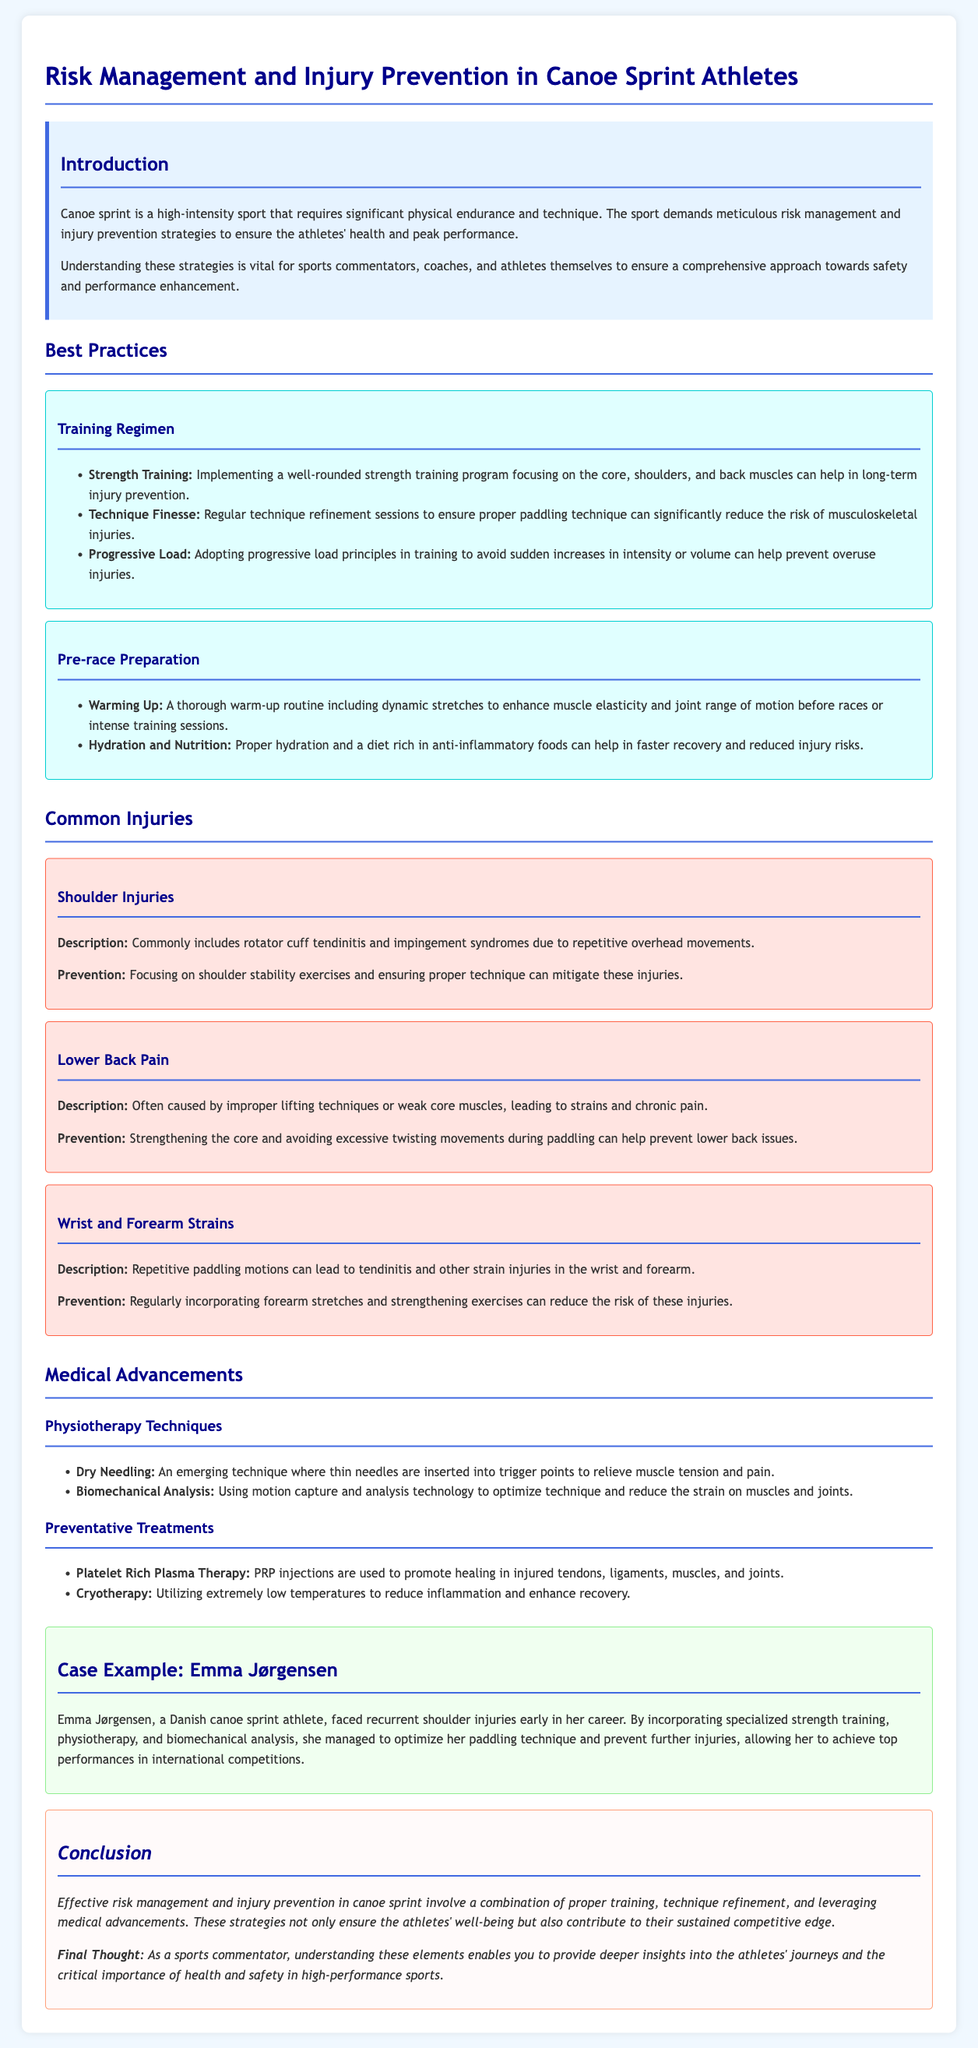What is the main focus of the case study? The case study primarily focuses on risk management and injury prevention in canoe sprint athletes.
Answer: Risk management and injury prevention in canoe sprint athletes What common injury is caused by repetitive overhead movements? The document mentions that rotator cuff tendinitis and impingement syndromes are common injuries related to repetitive overhead movements.
Answer: Shoulder injuries What does PRP stand for in medical advancements? The abbreviation PRP refers to Platelet Rich Plasma, which is used in preventative treatments.
Answer: Platelet Rich Plasma How can athletes prevent lower back pain? According to the document, prevention can be achieved by strengthening the core and avoiding excessive twisting movements during paddling.
Answer: Strengthening the core Who is the case example focused on? The case example highlights the achievements and injury management of a specific athlete named Emma Jørgensen.
Answer: Emma Jørgensen What aspect of training helps prevent overuse injuries? The document states that adopting progressive load principles in training can help prevent overuse injuries.
Answer: Progressive load principles What technique is used to relieve muscle tension according to medical advancements? The document explains that dry needling is used for relieving muscle tension and pain.
Answer: Dry Needling What time of routine is essential before races? A thorough warm-up routine is emphasized as essential before races or intense training sessions.
Answer: Warm-up routine What type of analysis helps optimize technique? The document mentions biomechanical analysis as a method to optimize technique for canoe sprint athletes.
Answer: Biomechanical analysis 